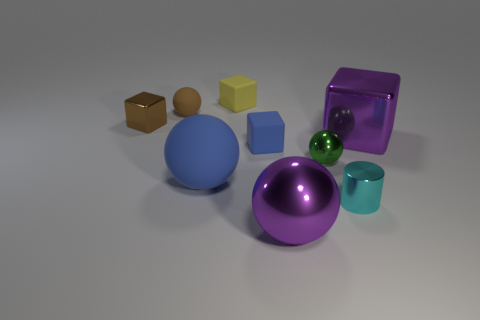Can you describe the texture and colors of the objects in the image? Certainly! The image shows a variety of objects with different textures and colors. The large purple object in the foreground has a glossy finish that reflects light, while the big blue sphere next to it has a matte texture. The colors range from neutral brown and beige for the two cubic objects on the left, to vibrant hues like cyan for the small cylinder, yellow for a small cube, and green for the small, shiny sphere. 